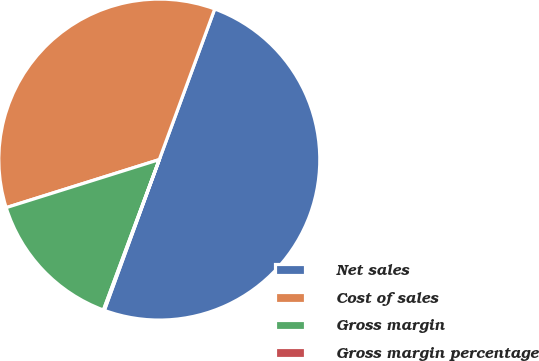Convert chart. <chart><loc_0><loc_0><loc_500><loc_500><pie_chart><fcel>Net sales<fcel>Cost of sales<fcel>Gross margin<fcel>Gross margin percentage<nl><fcel>49.95%<fcel>35.45%<fcel>14.5%<fcel>0.1%<nl></chart> 